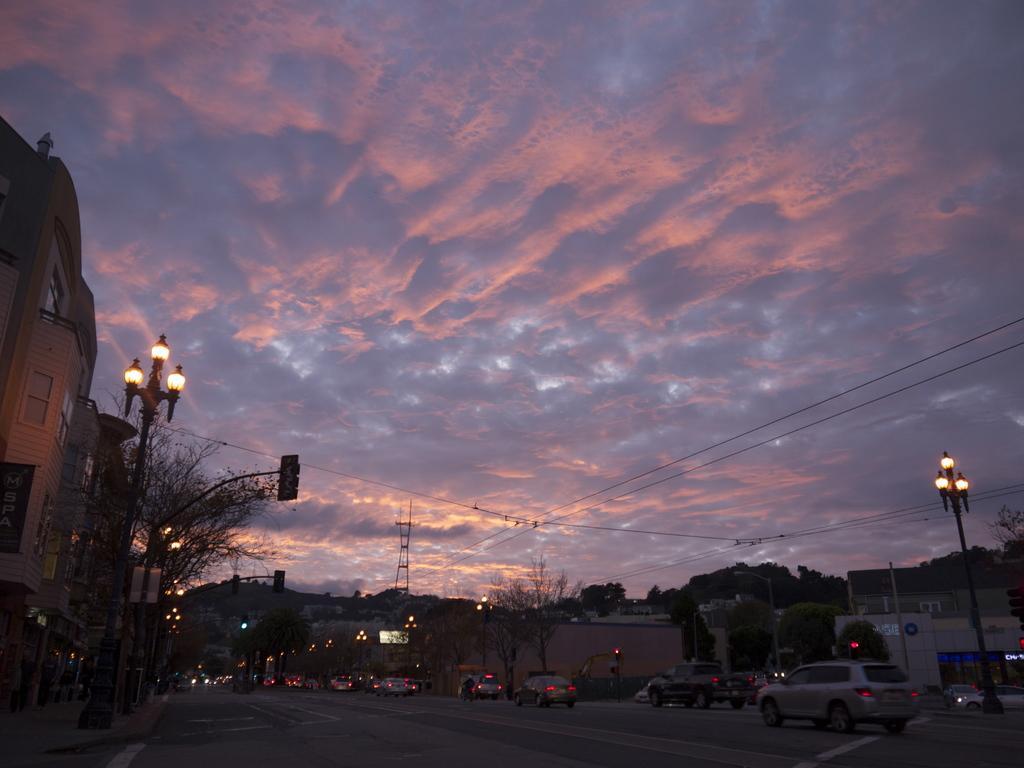Can you describe this image briefly? We can see vehicles on the road and we can see lights and traffic signals on poles and building. Background we can see trees and sky with clouds. We can see wires. 